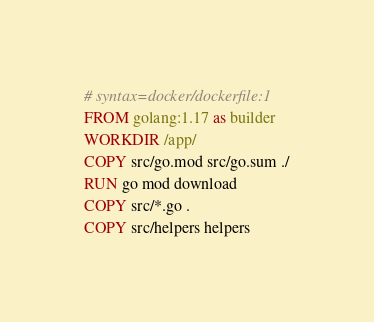<code> <loc_0><loc_0><loc_500><loc_500><_Dockerfile_># syntax=docker/dockerfile:1
FROM golang:1.17 as builder
WORKDIR /app/
COPY src/go.mod src/go.sum ./
RUN go mod download
COPY src/*.go .
COPY src/helpers helpers</code> 